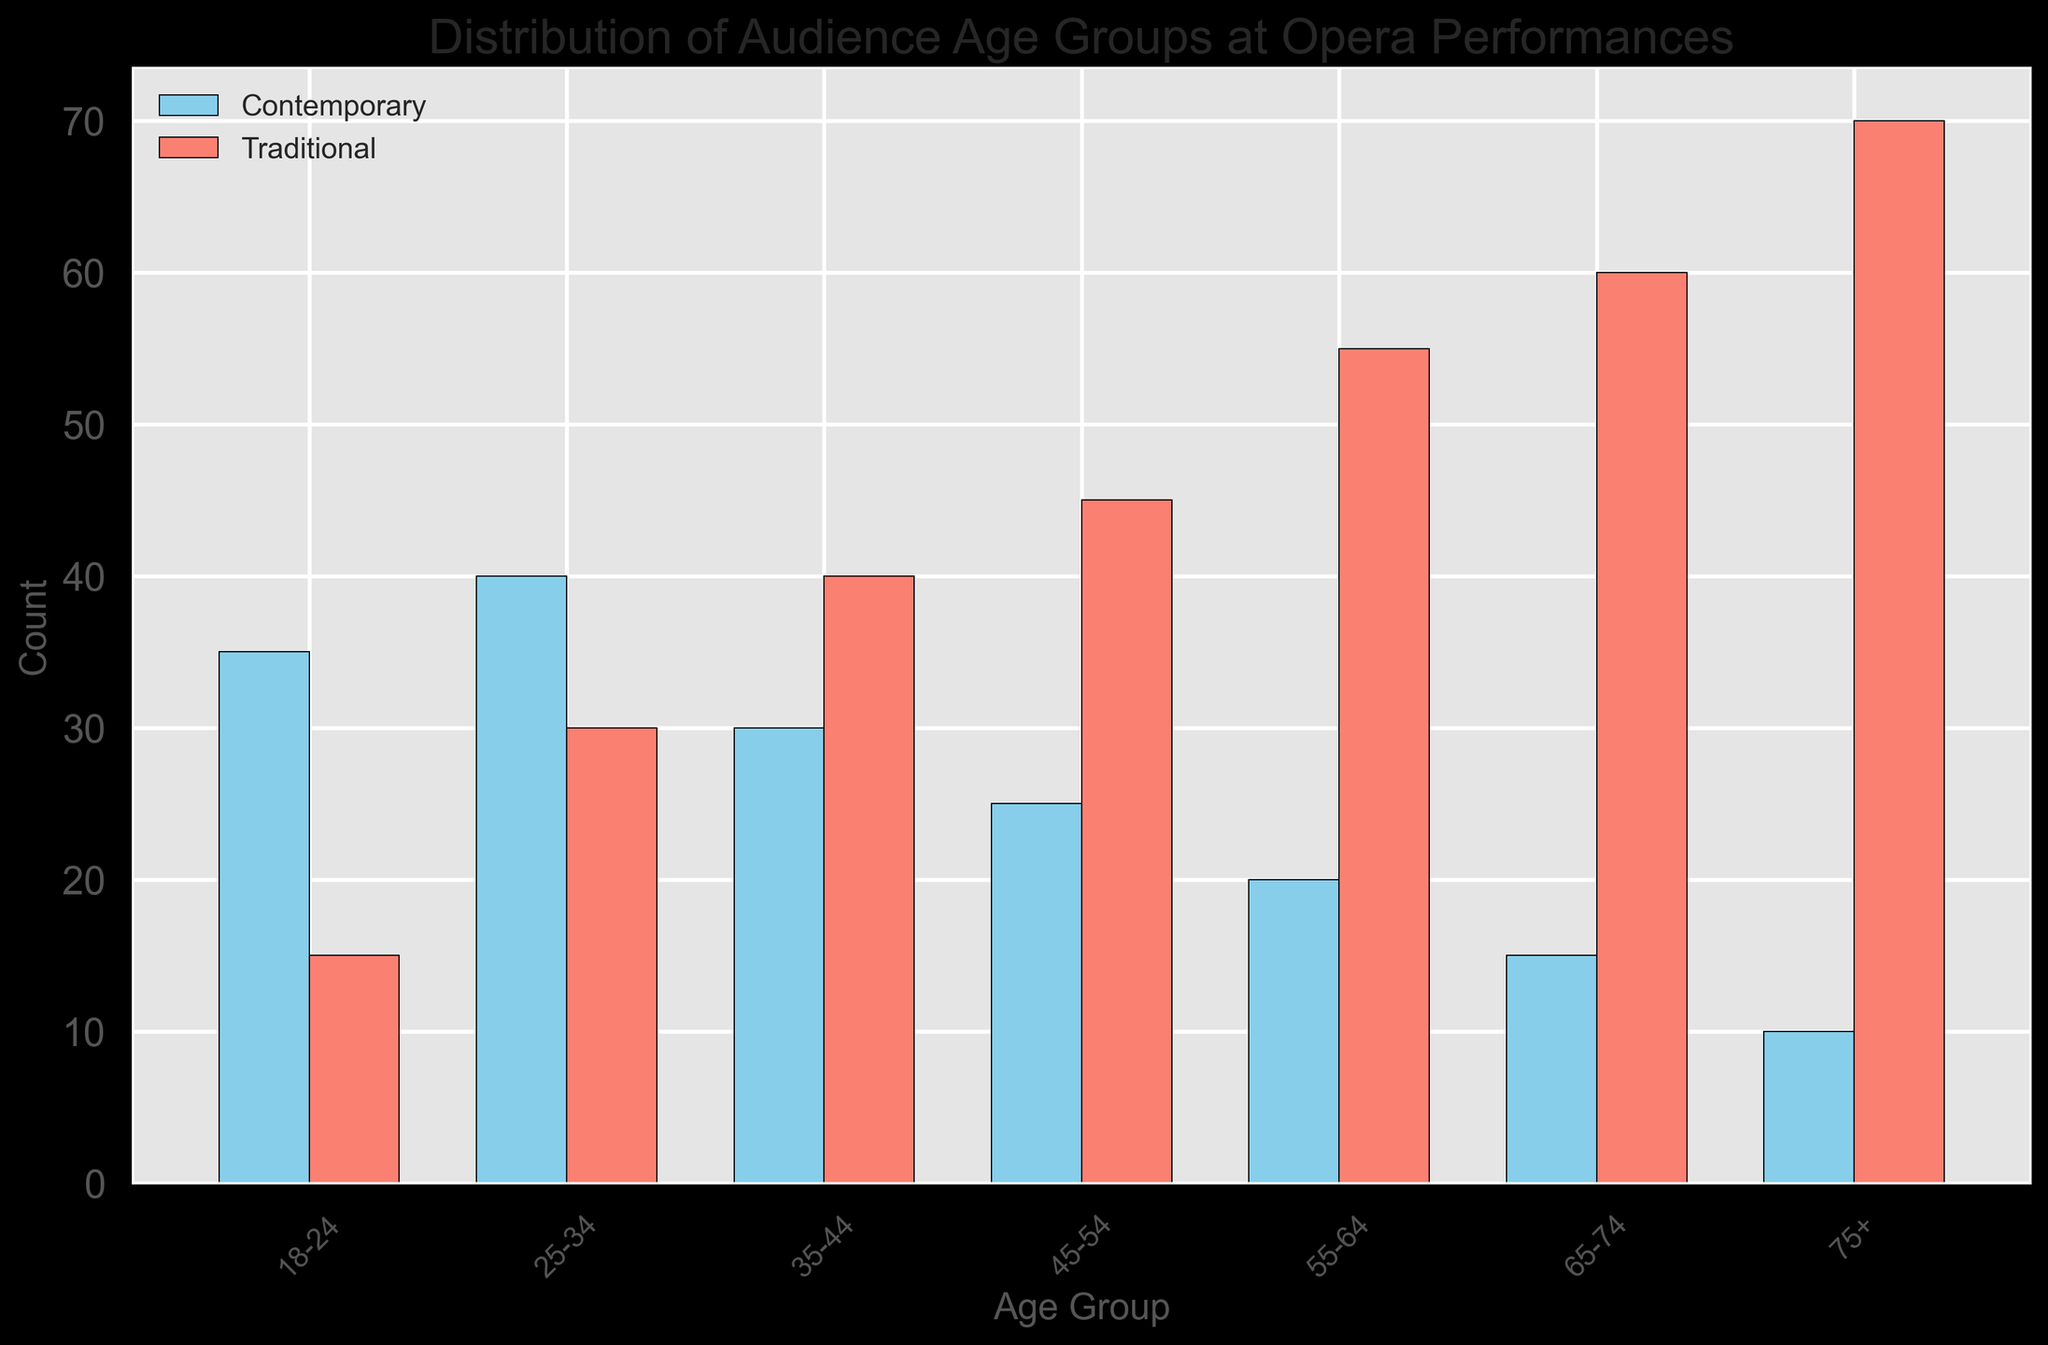Which age group has the highest audience count for traditional opera performances? Identify the highest bar among the traditional performance categories (colored in salmon) by visually assessing their height. The bar representing the 75+ age group is the tallest among them.
Answer: 75+ Which age group has a higher attendance for contemporary opera than traditional opera? Compare the heights of bars between contemporary (skyblue) and traditional (salmon) for each age group. Only the 18-24 and 25-34 age group bars for contemporary performances are taller than those for traditional performances.
Answer: 18-24, 25-34 What is the total audience count for the age groups 35-44 and 45-54 in traditional opera performances? Sum the counts for the 35-44 (40) and 45-54 (45) age groups from the traditional opera performance category. 40 + 45 = 85
Answer: 85 What is the age range with the lowest attendance for contemporary opera performances? Identify the smallest bar in the contemporary category (skyblue). The 75+ age group bar is the smallest.
Answer: 75+ How much larger is the audience count for the 55-64 age group in traditional opera than in contemporary opera? Subtract the contemporary performance count (20) from the traditional performance count (55) for the 55-64 age group. 55 - 20 = 35
Answer: 35 What are the performance types with the highest audience count for the age groups 65-74 and 75+? Identify the tallest bars for the age groups 65-74 and 75+. Both have higher bars in the traditional category (salmon).
Answer: Traditional What is the difference between the youngest age group (18-24) audience counts for contemporary and traditional opera performances? Subtract the traditional performance count (15) from the contemporary performance count (35) for the 18-24 age group. 35 - 15 = 20
Answer: 20 What is the average audience count for contemporary opera across all age groups? Sum all the counts of contemporary performances (35 + 40 + 30 + 25 + 20 + 15 + 10 = 175) and divide by the number of age groups (7). 175 / 7 ≈ 25
Answer: 25 Which age group has a similar audience count for both contemporary and traditional opera performances? Observe the bars for both performance types and compare their height. The counts for the age group 35-44 (traditional: 40, contemporary: 30) are closest among all the comparisons.
Answer: 35-44 Which age group shows the largest discrepancy in audience count between contemporary and traditional operas? Identify the largest difference by comparing the heights of bars for each age group. The 75+ age group shows the largest discrepancy between contemporary (10) and traditional (70) performances. 70 - 10 = 60
Answer: 75+ 